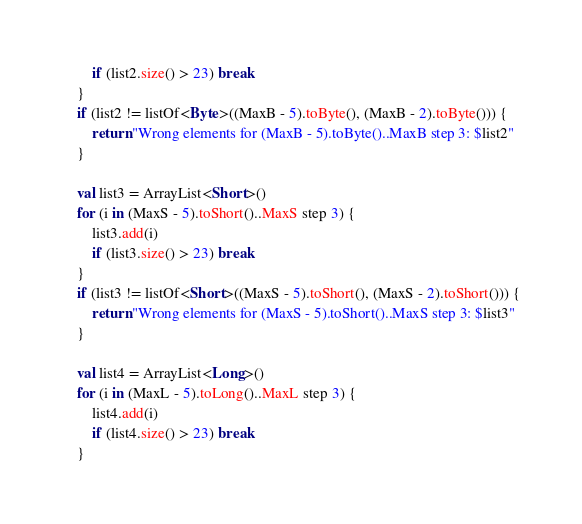<code> <loc_0><loc_0><loc_500><loc_500><_Kotlin_>        if (list2.size() > 23) break
    }
    if (list2 != listOf<Byte>((MaxB - 5).toByte(), (MaxB - 2).toByte())) {
        return "Wrong elements for (MaxB - 5).toByte()..MaxB step 3: $list2"
    }

    val list3 = ArrayList<Short>()
    for (i in (MaxS - 5).toShort()..MaxS step 3) {
        list3.add(i)
        if (list3.size() > 23) break
    }
    if (list3 != listOf<Short>((MaxS - 5).toShort(), (MaxS - 2).toShort())) {
        return "Wrong elements for (MaxS - 5).toShort()..MaxS step 3: $list3"
    }

    val list4 = ArrayList<Long>()
    for (i in (MaxL - 5).toLong()..MaxL step 3) {
        list4.add(i)
        if (list4.size() > 23) break
    }</code> 